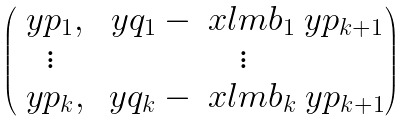<formula> <loc_0><loc_0><loc_500><loc_500>\begin{pmatrix} \ y p _ { 1 } , & \ y q _ { 1 } - \ x l m b _ { 1 } \ y p _ { k + 1 } \\ \vdots & \vdots \\ \ y p _ { k } , & \ y q _ { k } - \ x l m b _ { k } \ y p _ { k + 1 } \end{pmatrix}</formula> 